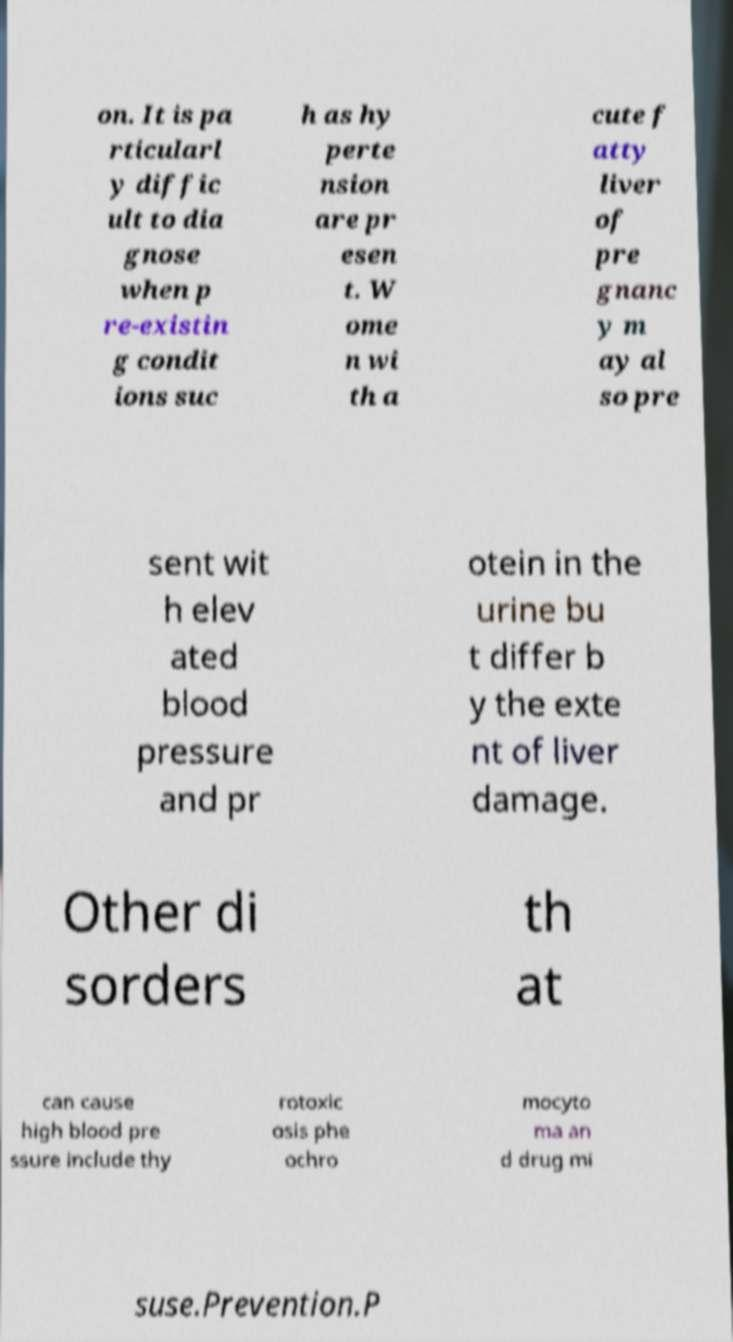For documentation purposes, I need the text within this image transcribed. Could you provide that? on. It is pa rticularl y diffic ult to dia gnose when p re-existin g condit ions suc h as hy perte nsion are pr esen t. W ome n wi th a cute f atty liver of pre gnanc y m ay al so pre sent wit h elev ated blood pressure and pr otein in the urine bu t differ b y the exte nt of liver damage. Other di sorders th at can cause high blood pre ssure include thy rotoxic osis phe ochro mocyto ma an d drug mi suse.Prevention.P 